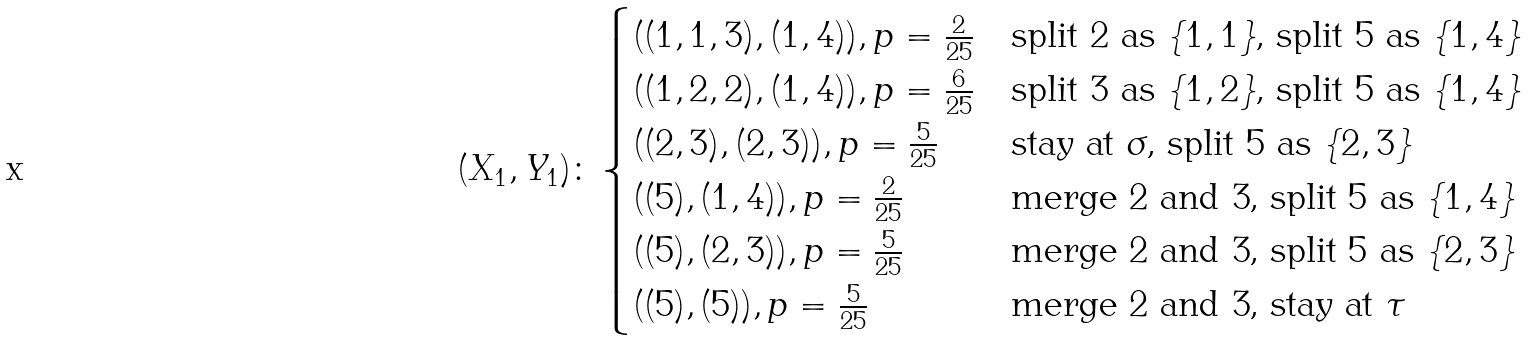Convert formula to latex. <formula><loc_0><loc_0><loc_500><loc_500>( X _ { 1 } , Y _ { 1 } ) \colon \begin{cases} ( ( 1 , 1 , 3 ) , ( 1 , 4 ) ) , p = \frac { 2 } { 2 5 } & \text {split $2$ as $\{1,1\}$, split $5$ as $\{1,4\}$} \\ ( ( 1 , 2 , 2 ) , ( 1 , 4 ) ) , p = \frac { 6 } { 2 5 } & \text {split $3$ as $\{1,2\}$, split $5$ as $\{1, 4\}$} \\ ( ( 2 , 3 ) , ( 2 , 3 ) ) , p = \frac { 5 } { 2 5 } & \text {stay at $\sigma$, split $5$ as $\{2, 3\}$} \\ ( ( 5 ) , ( 1 , 4 ) ) , p = \frac { 2 } { 2 5 } & \text {merge $2$ and $3$, split $5$ as $\{1,4\}$} \\ ( ( 5 ) , ( 2 , 3 ) ) , p = \frac { 5 } { 2 5 } & \text {merge $2$ and $3$, split $5$ as $\{2,3\}$} \\ ( ( 5 ) , ( 5 ) ) , p = \frac { 5 } { 2 5 } & \text {merge $2$ and $3$, stay at $\tau$} \end{cases}</formula> 